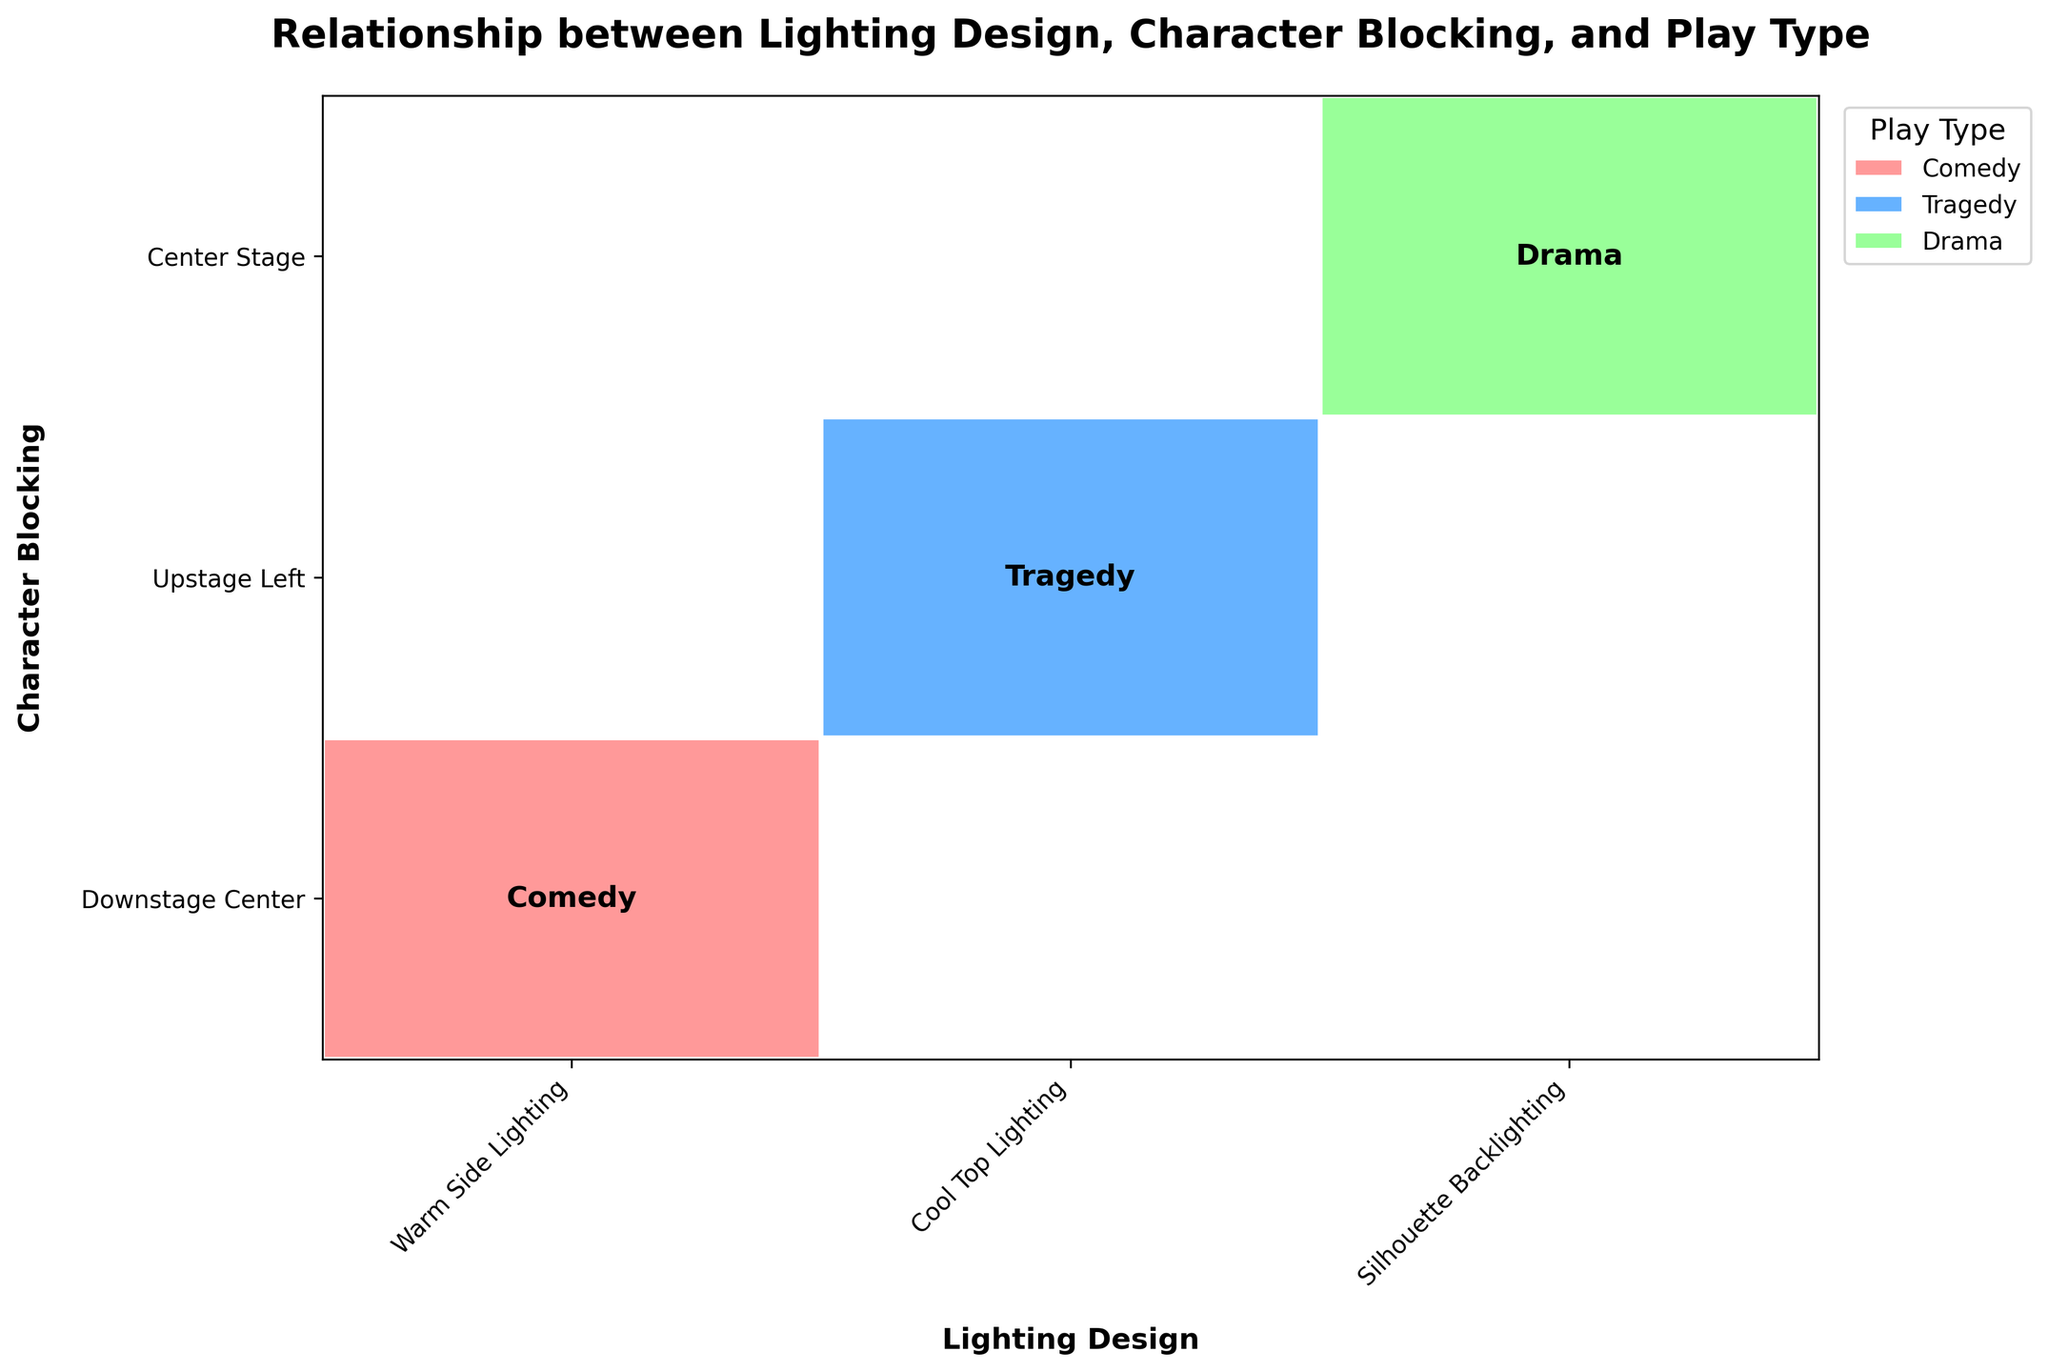What is the title of the plot? The title of the plot is usually seen at the top of the plot and gives an indication of what the plot is about.
Answer: Relationship between Lighting Design, Character Blocking, and Play Type How many unique lighting designs are represented in the plot? Count the number of unique lighting design labels along the x-axis to find the number of different lighting designs.
Answer: 3 Which lighting design is paired with 'Center Stage' character blocking in a drama play? Locate the 'Center Stage' point on the y-axis, then find the corresponding rectangle with the label 'Drama' inside it.
Answer: Silhouette Backlighting Are there any character blockings that are paired with all three play types? Look at each character blocking on the y-axis and see if it intersects with all rectangles that label 'Comedy,' 'Tragedy,' and 'Drama.'
Answer: No Which play type uses 'Warm Side Lighting' and 'Downstage Center' blocking? Find the combination of 'Warm Side Lighting' and 'Downstage Center' on the x and y axes, respectively, then check the label inside the corresponding rectangle.
Answer: Comedy How many rectangles are present in the plot? Count each rectangle present within the plot area. These rectangles correspond to unique combinations of lighting design, character blocking, and play type.
Answer: 3 Which blocking position appears most frequently among the plotted data points? Look at the y-axis and see which character blocking position intersects with the most number of rectangles.
Answer: Each blocking position appears once Compare the number of blocking positions for 'Cool Top Lighting' vs 'Silhouette Backlighting.' Count how many rectangles are present for each of the lighting designs.
Answer: Both have 1 What colors represent Comedy, Tragedy, and Drama respectively in the plot? Look at the color of the rectangles and match them to their respective play type labels.
Answer: #FF9999 for Comedy, #66B2FF for Tragedy, #99FF99 for Drama Does any lighting design appear more frequently in one particular play type? Check if any lighting design intersects with more than one rectangle of the same play type.
Answer: No 